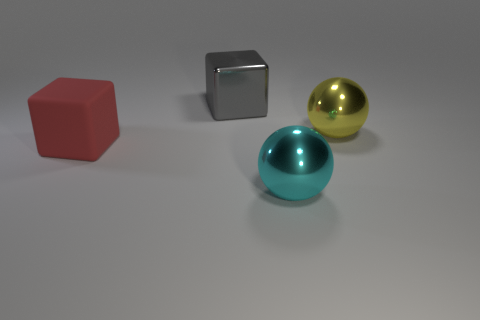There is a sphere in front of the big yellow ball; what is it made of?
Make the answer very short. Metal. How many other rubber blocks are the same color as the matte block?
Provide a short and direct response. 0. The cyan object that is made of the same material as the large yellow sphere is what size?
Your response must be concise. Large. What number of objects are gray metal cubes or red spheres?
Offer a very short reply. 1. What color is the large metal ball that is in front of the large red object?
Keep it short and to the point. Cyan. The cyan object that is the same shape as the big yellow metallic thing is what size?
Your answer should be very brief. Large. How many objects are large blocks behind the large yellow object or metallic spheres in front of the big red rubber object?
Keep it short and to the point. 2. What is the size of the object that is on the right side of the matte object and to the left of the cyan sphere?
Your answer should be compact. Large. There is a yellow metal object; does it have the same shape as the big thing that is to the left of the big gray cube?
Your answer should be very brief. No. What number of things are balls that are behind the large red matte thing or gray things?
Provide a short and direct response. 2. 